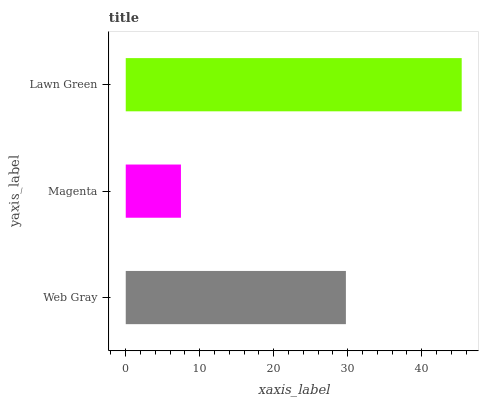Is Magenta the minimum?
Answer yes or no. Yes. Is Lawn Green the maximum?
Answer yes or no. Yes. Is Lawn Green the minimum?
Answer yes or no. No. Is Magenta the maximum?
Answer yes or no. No. Is Lawn Green greater than Magenta?
Answer yes or no. Yes. Is Magenta less than Lawn Green?
Answer yes or no. Yes. Is Magenta greater than Lawn Green?
Answer yes or no. No. Is Lawn Green less than Magenta?
Answer yes or no. No. Is Web Gray the high median?
Answer yes or no. Yes. Is Web Gray the low median?
Answer yes or no. Yes. Is Lawn Green the high median?
Answer yes or no. No. Is Magenta the low median?
Answer yes or no. No. 